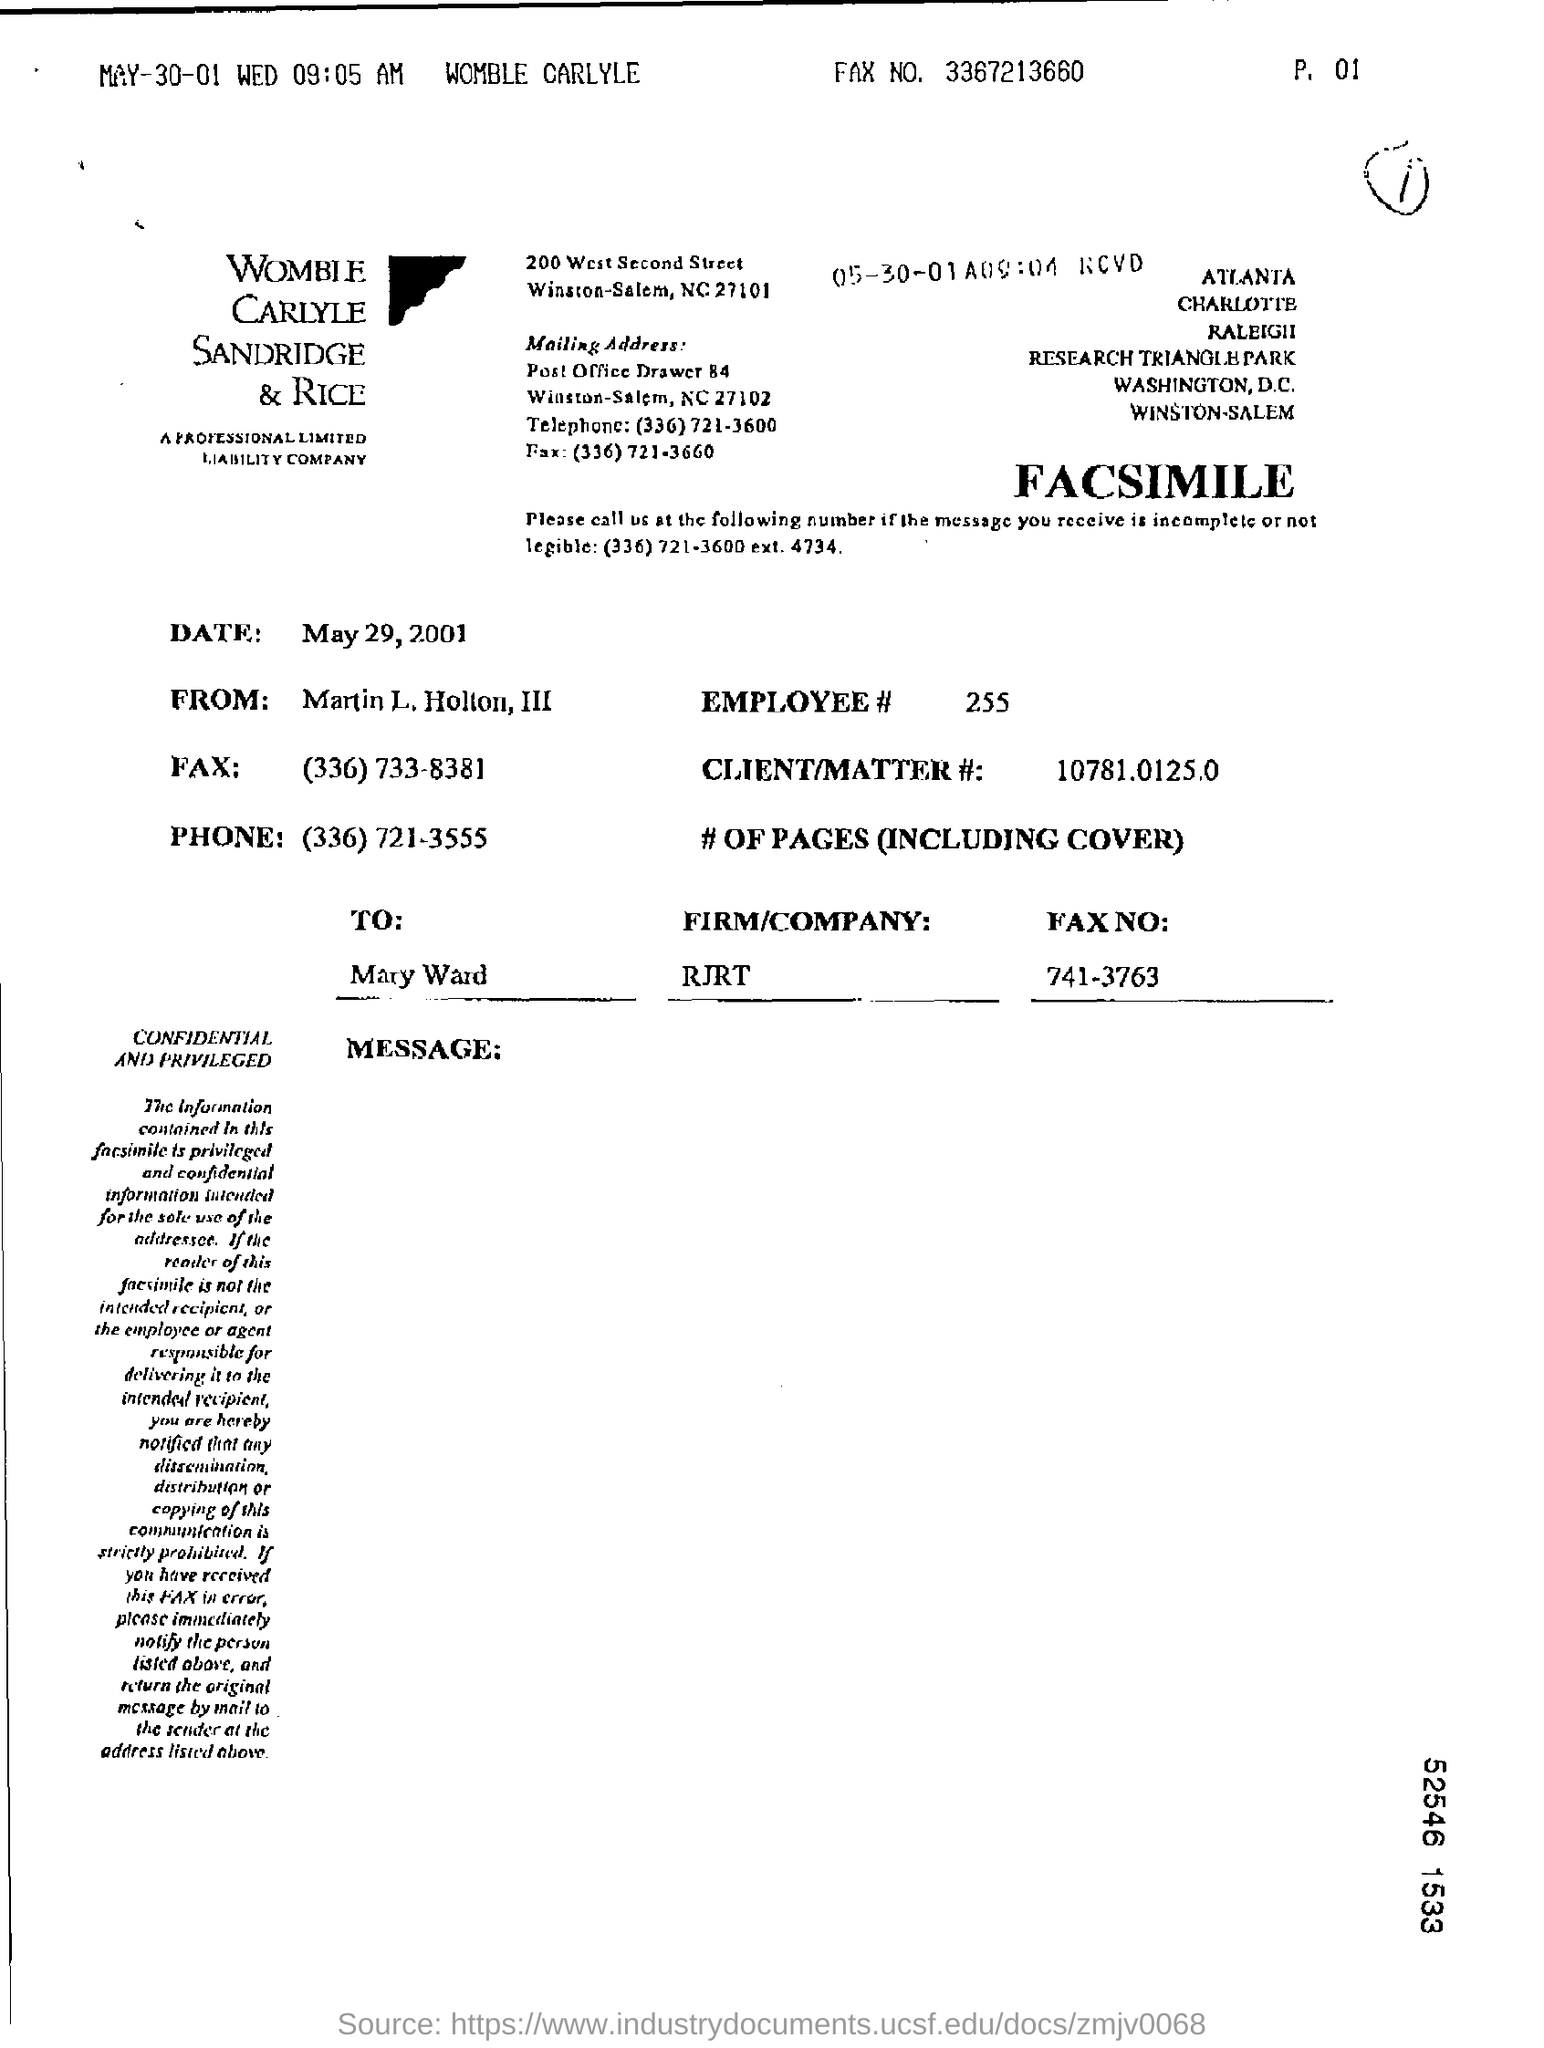What is the Employee#?
Ensure brevity in your answer.  255. What is the Client/Matter #?
Keep it short and to the point. 10781.0125.0. To Whom is this letter addressed to?
Provide a short and direct response. MARY WARD. 